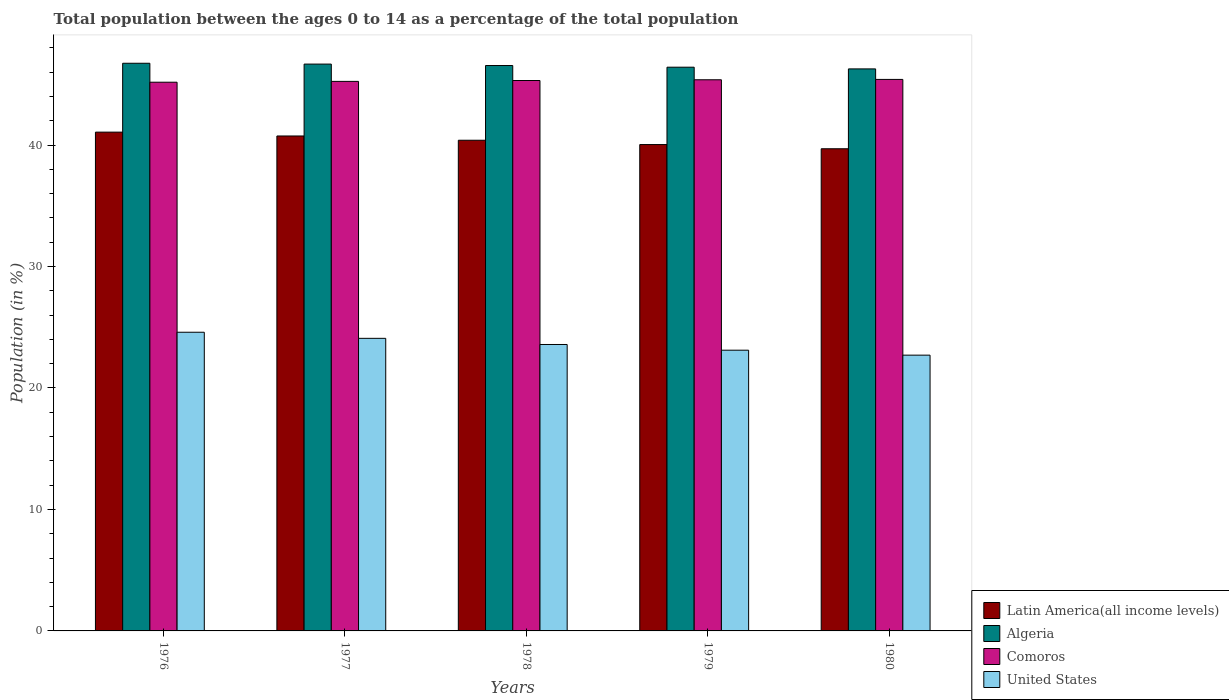How many bars are there on the 2nd tick from the left?
Your answer should be very brief. 4. What is the label of the 3rd group of bars from the left?
Ensure brevity in your answer.  1978. In how many cases, is the number of bars for a given year not equal to the number of legend labels?
Give a very brief answer. 0. What is the percentage of the population ages 0 to 14 in Latin America(all income levels) in 1977?
Make the answer very short. 40.75. Across all years, what is the maximum percentage of the population ages 0 to 14 in United States?
Give a very brief answer. 24.59. Across all years, what is the minimum percentage of the population ages 0 to 14 in Latin America(all income levels)?
Keep it short and to the point. 39.7. In which year was the percentage of the population ages 0 to 14 in Algeria maximum?
Your response must be concise. 1976. In which year was the percentage of the population ages 0 to 14 in Latin America(all income levels) minimum?
Keep it short and to the point. 1980. What is the total percentage of the population ages 0 to 14 in Comoros in the graph?
Your answer should be very brief. 226.52. What is the difference between the percentage of the population ages 0 to 14 in Algeria in 1976 and that in 1977?
Keep it short and to the point. 0.07. What is the difference between the percentage of the population ages 0 to 14 in Latin America(all income levels) in 1976 and the percentage of the population ages 0 to 14 in Comoros in 1978?
Give a very brief answer. -4.25. What is the average percentage of the population ages 0 to 14 in Comoros per year?
Give a very brief answer. 45.3. In the year 1980, what is the difference between the percentage of the population ages 0 to 14 in Comoros and percentage of the population ages 0 to 14 in United States?
Your answer should be very brief. 22.7. What is the ratio of the percentage of the population ages 0 to 14 in Comoros in 1976 to that in 1977?
Provide a succinct answer. 1. Is the percentage of the population ages 0 to 14 in Algeria in 1978 less than that in 1980?
Make the answer very short. No. Is the difference between the percentage of the population ages 0 to 14 in Comoros in 1976 and 1979 greater than the difference between the percentage of the population ages 0 to 14 in United States in 1976 and 1979?
Your response must be concise. No. What is the difference between the highest and the second highest percentage of the population ages 0 to 14 in Algeria?
Give a very brief answer. 0.07. What is the difference between the highest and the lowest percentage of the population ages 0 to 14 in Comoros?
Give a very brief answer. 0.23. In how many years, is the percentage of the population ages 0 to 14 in Algeria greater than the average percentage of the population ages 0 to 14 in Algeria taken over all years?
Make the answer very short. 3. Is the sum of the percentage of the population ages 0 to 14 in Algeria in 1976 and 1977 greater than the maximum percentage of the population ages 0 to 14 in Latin America(all income levels) across all years?
Offer a terse response. Yes. What does the 2nd bar from the left in 1980 represents?
Offer a terse response. Algeria. What does the 2nd bar from the right in 1977 represents?
Give a very brief answer. Comoros. Is it the case that in every year, the sum of the percentage of the population ages 0 to 14 in Comoros and percentage of the population ages 0 to 14 in Algeria is greater than the percentage of the population ages 0 to 14 in Latin America(all income levels)?
Provide a succinct answer. Yes. How many bars are there?
Keep it short and to the point. 20. Are the values on the major ticks of Y-axis written in scientific E-notation?
Your answer should be very brief. No. How many legend labels are there?
Your answer should be compact. 4. How are the legend labels stacked?
Make the answer very short. Vertical. What is the title of the graph?
Your response must be concise. Total population between the ages 0 to 14 as a percentage of the total population. What is the label or title of the X-axis?
Provide a succinct answer. Years. What is the Population (in %) in Latin America(all income levels) in 1976?
Offer a very short reply. 41.07. What is the Population (in %) of Algeria in 1976?
Provide a short and direct response. 46.74. What is the Population (in %) of Comoros in 1976?
Offer a terse response. 45.18. What is the Population (in %) of United States in 1976?
Provide a succinct answer. 24.59. What is the Population (in %) in Latin America(all income levels) in 1977?
Provide a short and direct response. 40.75. What is the Population (in %) in Algeria in 1977?
Your answer should be very brief. 46.67. What is the Population (in %) of Comoros in 1977?
Your response must be concise. 45.24. What is the Population (in %) in United States in 1977?
Make the answer very short. 24.09. What is the Population (in %) of Latin America(all income levels) in 1978?
Ensure brevity in your answer.  40.4. What is the Population (in %) in Algeria in 1978?
Offer a very short reply. 46.55. What is the Population (in %) in Comoros in 1978?
Ensure brevity in your answer.  45.32. What is the Population (in %) of United States in 1978?
Your answer should be compact. 23.58. What is the Population (in %) in Latin America(all income levels) in 1979?
Ensure brevity in your answer.  40.04. What is the Population (in %) in Algeria in 1979?
Your answer should be very brief. 46.41. What is the Population (in %) in Comoros in 1979?
Your answer should be compact. 45.38. What is the Population (in %) of United States in 1979?
Your response must be concise. 23.11. What is the Population (in %) of Latin America(all income levels) in 1980?
Your answer should be compact. 39.7. What is the Population (in %) in Algeria in 1980?
Your response must be concise. 46.27. What is the Population (in %) in Comoros in 1980?
Make the answer very short. 45.41. What is the Population (in %) of United States in 1980?
Offer a terse response. 22.7. Across all years, what is the maximum Population (in %) of Latin America(all income levels)?
Provide a short and direct response. 41.07. Across all years, what is the maximum Population (in %) of Algeria?
Offer a terse response. 46.74. Across all years, what is the maximum Population (in %) of Comoros?
Your answer should be compact. 45.41. Across all years, what is the maximum Population (in %) of United States?
Your answer should be compact. 24.59. Across all years, what is the minimum Population (in %) in Latin America(all income levels)?
Provide a succinct answer. 39.7. Across all years, what is the minimum Population (in %) in Algeria?
Keep it short and to the point. 46.27. Across all years, what is the minimum Population (in %) of Comoros?
Provide a short and direct response. 45.18. Across all years, what is the minimum Population (in %) of United States?
Provide a short and direct response. 22.7. What is the total Population (in %) in Latin America(all income levels) in the graph?
Provide a short and direct response. 201.95. What is the total Population (in %) in Algeria in the graph?
Provide a short and direct response. 232.64. What is the total Population (in %) in Comoros in the graph?
Offer a very short reply. 226.52. What is the total Population (in %) of United States in the graph?
Your answer should be compact. 118.08. What is the difference between the Population (in %) in Latin America(all income levels) in 1976 and that in 1977?
Your response must be concise. 0.32. What is the difference between the Population (in %) in Algeria in 1976 and that in 1977?
Your response must be concise. 0.07. What is the difference between the Population (in %) in Comoros in 1976 and that in 1977?
Your answer should be very brief. -0.07. What is the difference between the Population (in %) in United States in 1976 and that in 1977?
Your response must be concise. 0.5. What is the difference between the Population (in %) of Latin America(all income levels) in 1976 and that in 1978?
Provide a succinct answer. 0.67. What is the difference between the Population (in %) of Algeria in 1976 and that in 1978?
Provide a succinct answer. 0.19. What is the difference between the Population (in %) of Comoros in 1976 and that in 1978?
Provide a succinct answer. -0.14. What is the difference between the Population (in %) of United States in 1976 and that in 1978?
Ensure brevity in your answer.  1.01. What is the difference between the Population (in %) in Latin America(all income levels) in 1976 and that in 1979?
Ensure brevity in your answer.  1.02. What is the difference between the Population (in %) in Algeria in 1976 and that in 1979?
Give a very brief answer. 0.32. What is the difference between the Population (in %) of Comoros in 1976 and that in 1979?
Your response must be concise. -0.2. What is the difference between the Population (in %) of United States in 1976 and that in 1979?
Your answer should be compact. 1.48. What is the difference between the Population (in %) in Latin America(all income levels) in 1976 and that in 1980?
Provide a succinct answer. 1.37. What is the difference between the Population (in %) of Algeria in 1976 and that in 1980?
Offer a terse response. 0.46. What is the difference between the Population (in %) in Comoros in 1976 and that in 1980?
Your answer should be compact. -0.23. What is the difference between the Population (in %) of United States in 1976 and that in 1980?
Provide a succinct answer. 1.89. What is the difference between the Population (in %) of Latin America(all income levels) in 1977 and that in 1978?
Your answer should be very brief. 0.35. What is the difference between the Population (in %) in Algeria in 1977 and that in 1978?
Offer a very short reply. 0.12. What is the difference between the Population (in %) in Comoros in 1977 and that in 1978?
Provide a succinct answer. -0.07. What is the difference between the Population (in %) in United States in 1977 and that in 1978?
Your answer should be very brief. 0.51. What is the difference between the Population (in %) in Latin America(all income levels) in 1977 and that in 1979?
Make the answer very short. 0.71. What is the difference between the Population (in %) of Algeria in 1977 and that in 1979?
Your response must be concise. 0.26. What is the difference between the Population (in %) of Comoros in 1977 and that in 1979?
Offer a very short reply. -0.13. What is the difference between the Population (in %) of Latin America(all income levels) in 1977 and that in 1980?
Your answer should be very brief. 1.05. What is the difference between the Population (in %) in Algeria in 1977 and that in 1980?
Give a very brief answer. 0.4. What is the difference between the Population (in %) in Comoros in 1977 and that in 1980?
Provide a succinct answer. -0.16. What is the difference between the Population (in %) in United States in 1977 and that in 1980?
Your response must be concise. 1.38. What is the difference between the Population (in %) of Latin America(all income levels) in 1978 and that in 1979?
Give a very brief answer. 0.36. What is the difference between the Population (in %) of Algeria in 1978 and that in 1979?
Your response must be concise. 0.14. What is the difference between the Population (in %) of Comoros in 1978 and that in 1979?
Your answer should be very brief. -0.06. What is the difference between the Population (in %) in United States in 1978 and that in 1979?
Offer a very short reply. 0.47. What is the difference between the Population (in %) of Latin America(all income levels) in 1978 and that in 1980?
Keep it short and to the point. 0.7. What is the difference between the Population (in %) of Algeria in 1978 and that in 1980?
Give a very brief answer. 0.28. What is the difference between the Population (in %) in Comoros in 1978 and that in 1980?
Your answer should be compact. -0.09. What is the difference between the Population (in %) of United States in 1978 and that in 1980?
Offer a terse response. 0.88. What is the difference between the Population (in %) of Latin America(all income levels) in 1979 and that in 1980?
Offer a very short reply. 0.35. What is the difference between the Population (in %) in Algeria in 1979 and that in 1980?
Your response must be concise. 0.14. What is the difference between the Population (in %) of Comoros in 1979 and that in 1980?
Make the answer very short. -0.03. What is the difference between the Population (in %) of United States in 1979 and that in 1980?
Provide a succinct answer. 0.41. What is the difference between the Population (in %) in Latin America(all income levels) in 1976 and the Population (in %) in Algeria in 1977?
Your answer should be compact. -5.6. What is the difference between the Population (in %) in Latin America(all income levels) in 1976 and the Population (in %) in Comoros in 1977?
Give a very brief answer. -4.18. What is the difference between the Population (in %) of Latin America(all income levels) in 1976 and the Population (in %) of United States in 1977?
Offer a terse response. 16.98. What is the difference between the Population (in %) in Algeria in 1976 and the Population (in %) in Comoros in 1977?
Provide a short and direct response. 1.49. What is the difference between the Population (in %) of Algeria in 1976 and the Population (in %) of United States in 1977?
Keep it short and to the point. 22.65. What is the difference between the Population (in %) in Comoros in 1976 and the Population (in %) in United States in 1977?
Offer a terse response. 21.09. What is the difference between the Population (in %) in Latin America(all income levels) in 1976 and the Population (in %) in Algeria in 1978?
Your response must be concise. -5.48. What is the difference between the Population (in %) in Latin America(all income levels) in 1976 and the Population (in %) in Comoros in 1978?
Offer a terse response. -4.25. What is the difference between the Population (in %) of Latin America(all income levels) in 1976 and the Population (in %) of United States in 1978?
Offer a very short reply. 17.48. What is the difference between the Population (in %) of Algeria in 1976 and the Population (in %) of Comoros in 1978?
Offer a terse response. 1.42. What is the difference between the Population (in %) in Algeria in 1976 and the Population (in %) in United States in 1978?
Provide a succinct answer. 23.15. What is the difference between the Population (in %) in Comoros in 1976 and the Population (in %) in United States in 1978?
Offer a very short reply. 21.59. What is the difference between the Population (in %) of Latin America(all income levels) in 1976 and the Population (in %) of Algeria in 1979?
Your answer should be very brief. -5.35. What is the difference between the Population (in %) of Latin America(all income levels) in 1976 and the Population (in %) of Comoros in 1979?
Keep it short and to the point. -4.31. What is the difference between the Population (in %) of Latin America(all income levels) in 1976 and the Population (in %) of United States in 1979?
Offer a very short reply. 17.95. What is the difference between the Population (in %) of Algeria in 1976 and the Population (in %) of Comoros in 1979?
Your answer should be very brief. 1.36. What is the difference between the Population (in %) of Algeria in 1976 and the Population (in %) of United States in 1979?
Provide a short and direct response. 23.62. What is the difference between the Population (in %) of Comoros in 1976 and the Population (in %) of United States in 1979?
Make the answer very short. 22.06. What is the difference between the Population (in %) in Latin America(all income levels) in 1976 and the Population (in %) in Algeria in 1980?
Provide a succinct answer. -5.21. What is the difference between the Population (in %) in Latin America(all income levels) in 1976 and the Population (in %) in Comoros in 1980?
Your response must be concise. -4.34. What is the difference between the Population (in %) in Latin America(all income levels) in 1976 and the Population (in %) in United States in 1980?
Make the answer very short. 18.36. What is the difference between the Population (in %) in Algeria in 1976 and the Population (in %) in Comoros in 1980?
Keep it short and to the point. 1.33. What is the difference between the Population (in %) in Algeria in 1976 and the Population (in %) in United States in 1980?
Ensure brevity in your answer.  24.03. What is the difference between the Population (in %) of Comoros in 1976 and the Population (in %) of United States in 1980?
Provide a succinct answer. 22.47. What is the difference between the Population (in %) in Latin America(all income levels) in 1977 and the Population (in %) in Algeria in 1978?
Ensure brevity in your answer.  -5.8. What is the difference between the Population (in %) in Latin America(all income levels) in 1977 and the Population (in %) in Comoros in 1978?
Keep it short and to the point. -4.57. What is the difference between the Population (in %) of Latin America(all income levels) in 1977 and the Population (in %) of United States in 1978?
Provide a short and direct response. 17.17. What is the difference between the Population (in %) in Algeria in 1977 and the Population (in %) in Comoros in 1978?
Make the answer very short. 1.35. What is the difference between the Population (in %) of Algeria in 1977 and the Population (in %) of United States in 1978?
Ensure brevity in your answer.  23.09. What is the difference between the Population (in %) of Comoros in 1977 and the Population (in %) of United States in 1978?
Ensure brevity in your answer.  21.66. What is the difference between the Population (in %) of Latin America(all income levels) in 1977 and the Population (in %) of Algeria in 1979?
Provide a short and direct response. -5.66. What is the difference between the Population (in %) in Latin America(all income levels) in 1977 and the Population (in %) in Comoros in 1979?
Your answer should be compact. -4.63. What is the difference between the Population (in %) of Latin America(all income levels) in 1977 and the Population (in %) of United States in 1979?
Make the answer very short. 17.64. What is the difference between the Population (in %) of Algeria in 1977 and the Population (in %) of Comoros in 1979?
Ensure brevity in your answer.  1.29. What is the difference between the Population (in %) of Algeria in 1977 and the Population (in %) of United States in 1979?
Your answer should be very brief. 23.56. What is the difference between the Population (in %) in Comoros in 1977 and the Population (in %) in United States in 1979?
Provide a short and direct response. 22.13. What is the difference between the Population (in %) of Latin America(all income levels) in 1977 and the Population (in %) of Algeria in 1980?
Offer a very short reply. -5.52. What is the difference between the Population (in %) of Latin America(all income levels) in 1977 and the Population (in %) of Comoros in 1980?
Offer a terse response. -4.66. What is the difference between the Population (in %) of Latin America(all income levels) in 1977 and the Population (in %) of United States in 1980?
Provide a short and direct response. 18.04. What is the difference between the Population (in %) of Algeria in 1977 and the Population (in %) of Comoros in 1980?
Provide a succinct answer. 1.26. What is the difference between the Population (in %) in Algeria in 1977 and the Population (in %) in United States in 1980?
Give a very brief answer. 23.96. What is the difference between the Population (in %) in Comoros in 1977 and the Population (in %) in United States in 1980?
Your answer should be very brief. 22.54. What is the difference between the Population (in %) of Latin America(all income levels) in 1978 and the Population (in %) of Algeria in 1979?
Provide a short and direct response. -6.01. What is the difference between the Population (in %) of Latin America(all income levels) in 1978 and the Population (in %) of Comoros in 1979?
Your answer should be very brief. -4.98. What is the difference between the Population (in %) of Latin America(all income levels) in 1978 and the Population (in %) of United States in 1979?
Your answer should be compact. 17.29. What is the difference between the Population (in %) in Algeria in 1978 and the Population (in %) in Comoros in 1979?
Ensure brevity in your answer.  1.17. What is the difference between the Population (in %) of Algeria in 1978 and the Population (in %) of United States in 1979?
Offer a very short reply. 23.44. What is the difference between the Population (in %) in Comoros in 1978 and the Population (in %) in United States in 1979?
Make the answer very short. 22.2. What is the difference between the Population (in %) of Latin America(all income levels) in 1978 and the Population (in %) of Algeria in 1980?
Offer a very short reply. -5.87. What is the difference between the Population (in %) of Latin America(all income levels) in 1978 and the Population (in %) of Comoros in 1980?
Your answer should be very brief. -5.01. What is the difference between the Population (in %) of Latin America(all income levels) in 1978 and the Population (in %) of United States in 1980?
Provide a succinct answer. 17.69. What is the difference between the Population (in %) of Algeria in 1978 and the Population (in %) of Comoros in 1980?
Your answer should be very brief. 1.14. What is the difference between the Population (in %) in Algeria in 1978 and the Population (in %) in United States in 1980?
Keep it short and to the point. 23.84. What is the difference between the Population (in %) in Comoros in 1978 and the Population (in %) in United States in 1980?
Provide a short and direct response. 22.61. What is the difference between the Population (in %) in Latin America(all income levels) in 1979 and the Population (in %) in Algeria in 1980?
Offer a terse response. -6.23. What is the difference between the Population (in %) of Latin America(all income levels) in 1979 and the Population (in %) of Comoros in 1980?
Provide a succinct answer. -5.36. What is the difference between the Population (in %) in Latin America(all income levels) in 1979 and the Population (in %) in United States in 1980?
Make the answer very short. 17.34. What is the difference between the Population (in %) of Algeria in 1979 and the Population (in %) of United States in 1980?
Ensure brevity in your answer.  23.71. What is the difference between the Population (in %) in Comoros in 1979 and the Population (in %) in United States in 1980?
Provide a short and direct response. 22.67. What is the average Population (in %) of Latin America(all income levels) per year?
Provide a short and direct response. 40.39. What is the average Population (in %) in Algeria per year?
Offer a very short reply. 46.53. What is the average Population (in %) in Comoros per year?
Your response must be concise. 45.3. What is the average Population (in %) of United States per year?
Ensure brevity in your answer.  23.62. In the year 1976, what is the difference between the Population (in %) of Latin America(all income levels) and Population (in %) of Algeria?
Make the answer very short. -5.67. In the year 1976, what is the difference between the Population (in %) of Latin America(all income levels) and Population (in %) of Comoros?
Offer a very short reply. -4.11. In the year 1976, what is the difference between the Population (in %) in Latin America(all income levels) and Population (in %) in United States?
Your response must be concise. 16.48. In the year 1976, what is the difference between the Population (in %) of Algeria and Population (in %) of Comoros?
Make the answer very short. 1.56. In the year 1976, what is the difference between the Population (in %) in Algeria and Population (in %) in United States?
Provide a succinct answer. 22.15. In the year 1976, what is the difference between the Population (in %) in Comoros and Population (in %) in United States?
Provide a short and direct response. 20.59. In the year 1977, what is the difference between the Population (in %) of Latin America(all income levels) and Population (in %) of Algeria?
Offer a terse response. -5.92. In the year 1977, what is the difference between the Population (in %) of Latin America(all income levels) and Population (in %) of Comoros?
Your answer should be very brief. -4.5. In the year 1977, what is the difference between the Population (in %) of Latin America(all income levels) and Population (in %) of United States?
Make the answer very short. 16.66. In the year 1977, what is the difference between the Population (in %) in Algeria and Population (in %) in Comoros?
Your answer should be compact. 1.42. In the year 1977, what is the difference between the Population (in %) of Algeria and Population (in %) of United States?
Your answer should be very brief. 22.58. In the year 1977, what is the difference between the Population (in %) of Comoros and Population (in %) of United States?
Keep it short and to the point. 21.16. In the year 1978, what is the difference between the Population (in %) of Latin America(all income levels) and Population (in %) of Algeria?
Your answer should be very brief. -6.15. In the year 1978, what is the difference between the Population (in %) of Latin America(all income levels) and Population (in %) of Comoros?
Your answer should be very brief. -4.92. In the year 1978, what is the difference between the Population (in %) in Latin America(all income levels) and Population (in %) in United States?
Give a very brief answer. 16.82. In the year 1978, what is the difference between the Population (in %) of Algeria and Population (in %) of Comoros?
Provide a short and direct response. 1.23. In the year 1978, what is the difference between the Population (in %) in Algeria and Population (in %) in United States?
Ensure brevity in your answer.  22.97. In the year 1978, what is the difference between the Population (in %) of Comoros and Population (in %) of United States?
Ensure brevity in your answer.  21.73. In the year 1979, what is the difference between the Population (in %) of Latin America(all income levels) and Population (in %) of Algeria?
Give a very brief answer. -6.37. In the year 1979, what is the difference between the Population (in %) in Latin America(all income levels) and Population (in %) in Comoros?
Ensure brevity in your answer.  -5.33. In the year 1979, what is the difference between the Population (in %) in Latin America(all income levels) and Population (in %) in United States?
Give a very brief answer. 16.93. In the year 1979, what is the difference between the Population (in %) of Algeria and Population (in %) of Comoros?
Give a very brief answer. 1.04. In the year 1979, what is the difference between the Population (in %) of Algeria and Population (in %) of United States?
Offer a very short reply. 23.3. In the year 1979, what is the difference between the Population (in %) of Comoros and Population (in %) of United States?
Ensure brevity in your answer.  22.26. In the year 1980, what is the difference between the Population (in %) in Latin America(all income levels) and Population (in %) in Algeria?
Offer a very short reply. -6.57. In the year 1980, what is the difference between the Population (in %) in Latin America(all income levels) and Population (in %) in Comoros?
Make the answer very short. -5.71. In the year 1980, what is the difference between the Population (in %) in Latin America(all income levels) and Population (in %) in United States?
Offer a terse response. 16.99. In the year 1980, what is the difference between the Population (in %) of Algeria and Population (in %) of Comoros?
Your answer should be compact. 0.87. In the year 1980, what is the difference between the Population (in %) in Algeria and Population (in %) in United States?
Your answer should be compact. 23.57. In the year 1980, what is the difference between the Population (in %) of Comoros and Population (in %) of United States?
Your response must be concise. 22.7. What is the ratio of the Population (in %) in Algeria in 1976 to that in 1977?
Your answer should be very brief. 1. What is the ratio of the Population (in %) of United States in 1976 to that in 1977?
Offer a very short reply. 1.02. What is the ratio of the Population (in %) in Latin America(all income levels) in 1976 to that in 1978?
Keep it short and to the point. 1.02. What is the ratio of the Population (in %) of United States in 1976 to that in 1978?
Give a very brief answer. 1.04. What is the ratio of the Population (in %) of Latin America(all income levels) in 1976 to that in 1979?
Provide a short and direct response. 1.03. What is the ratio of the Population (in %) of Comoros in 1976 to that in 1979?
Ensure brevity in your answer.  1. What is the ratio of the Population (in %) of United States in 1976 to that in 1979?
Your response must be concise. 1.06. What is the ratio of the Population (in %) in Latin America(all income levels) in 1976 to that in 1980?
Your response must be concise. 1.03. What is the ratio of the Population (in %) of Algeria in 1976 to that in 1980?
Ensure brevity in your answer.  1.01. What is the ratio of the Population (in %) of United States in 1976 to that in 1980?
Provide a succinct answer. 1.08. What is the ratio of the Population (in %) in Latin America(all income levels) in 1977 to that in 1978?
Offer a terse response. 1.01. What is the ratio of the Population (in %) in Algeria in 1977 to that in 1978?
Keep it short and to the point. 1. What is the ratio of the Population (in %) in United States in 1977 to that in 1978?
Offer a very short reply. 1.02. What is the ratio of the Population (in %) in Latin America(all income levels) in 1977 to that in 1979?
Make the answer very short. 1.02. What is the ratio of the Population (in %) of United States in 1977 to that in 1979?
Give a very brief answer. 1.04. What is the ratio of the Population (in %) in Latin America(all income levels) in 1977 to that in 1980?
Offer a terse response. 1.03. What is the ratio of the Population (in %) of Algeria in 1977 to that in 1980?
Keep it short and to the point. 1.01. What is the ratio of the Population (in %) in United States in 1977 to that in 1980?
Keep it short and to the point. 1.06. What is the ratio of the Population (in %) of Latin America(all income levels) in 1978 to that in 1979?
Keep it short and to the point. 1.01. What is the ratio of the Population (in %) of Algeria in 1978 to that in 1979?
Offer a terse response. 1. What is the ratio of the Population (in %) of United States in 1978 to that in 1979?
Give a very brief answer. 1.02. What is the ratio of the Population (in %) of Latin America(all income levels) in 1978 to that in 1980?
Provide a short and direct response. 1.02. What is the ratio of the Population (in %) in Algeria in 1978 to that in 1980?
Give a very brief answer. 1.01. What is the ratio of the Population (in %) of United States in 1978 to that in 1980?
Provide a short and direct response. 1.04. What is the ratio of the Population (in %) in Latin America(all income levels) in 1979 to that in 1980?
Give a very brief answer. 1.01. What is the ratio of the Population (in %) in Comoros in 1979 to that in 1980?
Your answer should be very brief. 1. What is the difference between the highest and the second highest Population (in %) in Latin America(all income levels)?
Your answer should be compact. 0.32. What is the difference between the highest and the second highest Population (in %) of Algeria?
Your response must be concise. 0.07. What is the difference between the highest and the second highest Population (in %) of Comoros?
Offer a terse response. 0.03. What is the difference between the highest and the second highest Population (in %) of United States?
Give a very brief answer. 0.5. What is the difference between the highest and the lowest Population (in %) in Latin America(all income levels)?
Provide a short and direct response. 1.37. What is the difference between the highest and the lowest Population (in %) of Algeria?
Offer a very short reply. 0.46. What is the difference between the highest and the lowest Population (in %) in Comoros?
Keep it short and to the point. 0.23. What is the difference between the highest and the lowest Population (in %) of United States?
Offer a terse response. 1.89. 